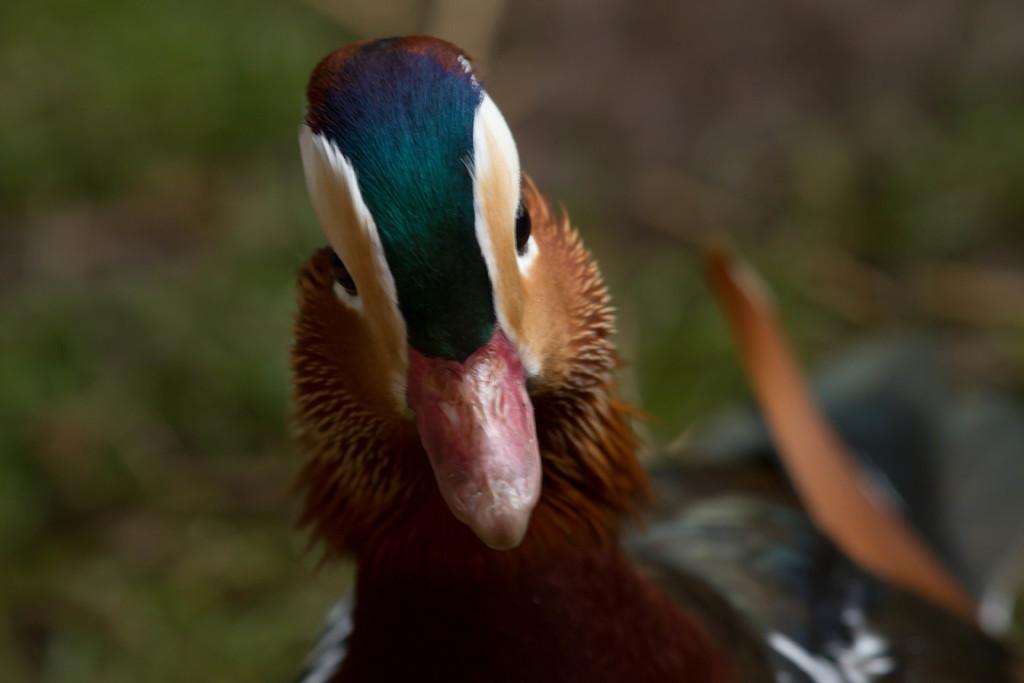Please provide a concise description of this image. In front of the image there is a duck and the background of the image is blur. 